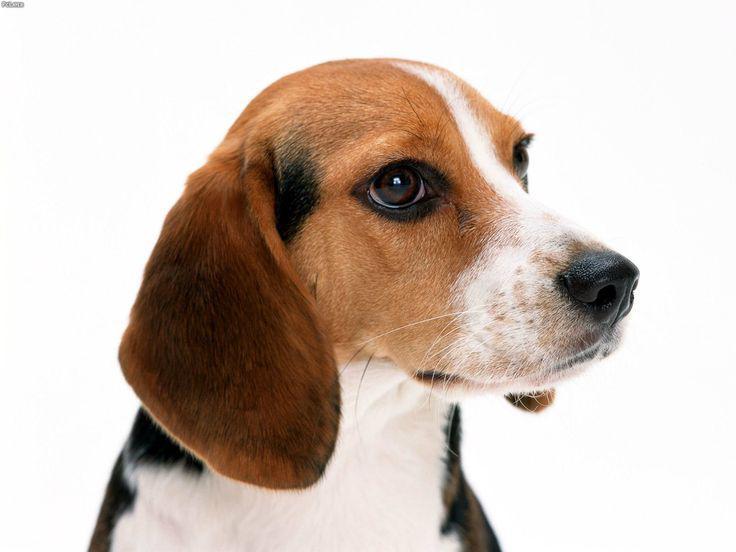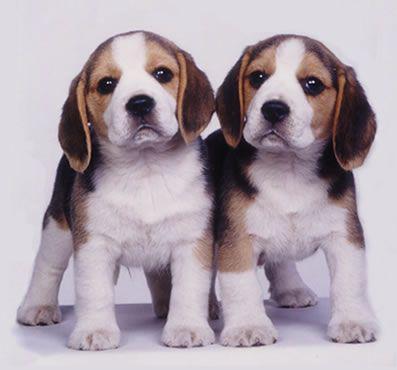The first image is the image on the left, the second image is the image on the right. Considering the images on both sides, is "The dogs in the image on the right are sitting on the ground outside." valid? Answer yes or no. No. The first image is the image on the left, the second image is the image on the right. Analyze the images presented: Is the assertion "There are 2 dogs standing on all fours in the right image." valid? Answer yes or no. Yes. 